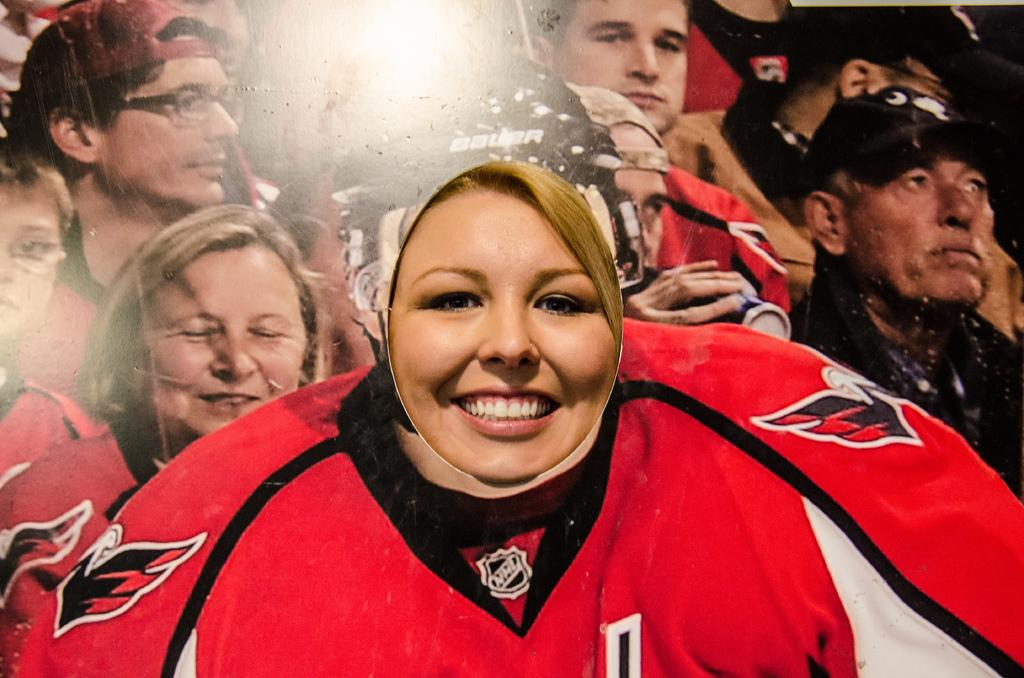Who is present in the image? There is a woman in the image. What can be seen on the woman's face? The woman's face is visible in the image. What is the woman standing behind? The woman is standing behind a banner. What is depicted on the banner? The banner features an audience watching a game. What type of boot is the woman wearing in the image? There is no information about the woman's footwear in the image, so it cannot be determined if she is wearing a boot or any other type of footwear. 